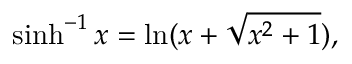<formula> <loc_0><loc_0><loc_500><loc_500>\sinh ^ { - 1 } { x } = \ln ( x + { \sqrt { x ^ { 2 } + 1 } } ) ,</formula> 